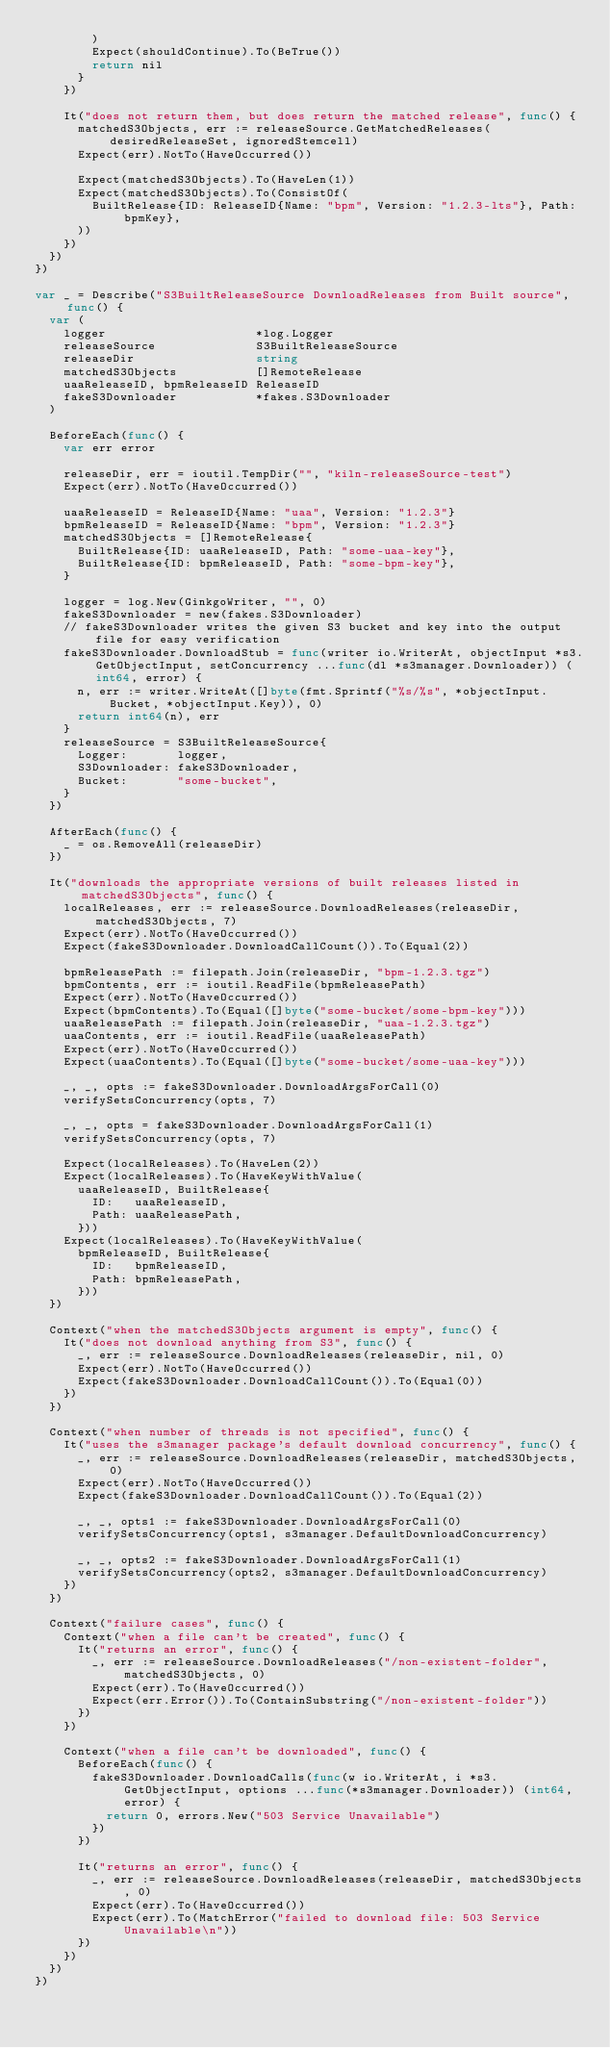<code> <loc_0><loc_0><loc_500><loc_500><_Go_>				)
				Expect(shouldContinue).To(BeTrue())
				return nil
			}
		})

		It("does not return them, but does return the matched release", func() {
			matchedS3Objects, err := releaseSource.GetMatchedReleases(desiredReleaseSet, ignoredStemcell)
			Expect(err).NotTo(HaveOccurred())

			Expect(matchedS3Objects).To(HaveLen(1))
			Expect(matchedS3Objects).To(ConsistOf(
				BuiltRelease{ID: ReleaseID{Name: "bpm", Version: "1.2.3-lts"}, Path: bpmKey},
			))
		})
	})
})

var _ = Describe("S3BuiltReleaseSource DownloadReleases from Built source", func() {
	var (
		logger                     *log.Logger
		releaseSource              S3BuiltReleaseSource
		releaseDir                 string
		matchedS3Objects           []RemoteRelease
		uaaReleaseID, bpmReleaseID ReleaseID
		fakeS3Downloader           *fakes.S3Downloader
	)

	BeforeEach(func() {
		var err error

		releaseDir, err = ioutil.TempDir("", "kiln-releaseSource-test")
		Expect(err).NotTo(HaveOccurred())

		uaaReleaseID = ReleaseID{Name: "uaa", Version: "1.2.3"}
		bpmReleaseID = ReleaseID{Name: "bpm", Version: "1.2.3"}
		matchedS3Objects = []RemoteRelease{
			BuiltRelease{ID: uaaReleaseID, Path: "some-uaa-key"},
			BuiltRelease{ID: bpmReleaseID, Path: "some-bpm-key"},
		}

		logger = log.New(GinkgoWriter, "", 0)
		fakeS3Downloader = new(fakes.S3Downloader)
		// fakeS3Downloader writes the given S3 bucket and key into the output file for easy verification
		fakeS3Downloader.DownloadStub = func(writer io.WriterAt, objectInput *s3.GetObjectInput, setConcurrency ...func(dl *s3manager.Downloader)) (int64, error) {
			n, err := writer.WriteAt([]byte(fmt.Sprintf("%s/%s", *objectInput.Bucket, *objectInput.Key)), 0)
			return int64(n), err
		}
		releaseSource = S3BuiltReleaseSource{
			Logger:       logger,
			S3Downloader: fakeS3Downloader,
			Bucket:       "some-bucket",
		}
	})

	AfterEach(func() {
		_ = os.RemoveAll(releaseDir)
	})

	It("downloads the appropriate versions of built releases listed in matchedS3Objects", func() {
		localReleases, err := releaseSource.DownloadReleases(releaseDir, matchedS3Objects, 7)
		Expect(err).NotTo(HaveOccurred())
		Expect(fakeS3Downloader.DownloadCallCount()).To(Equal(2))

		bpmReleasePath := filepath.Join(releaseDir, "bpm-1.2.3.tgz")
		bpmContents, err := ioutil.ReadFile(bpmReleasePath)
		Expect(err).NotTo(HaveOccurred())
		Expect(bpmContents).To(Equal([]byte("some-bucket/some-bpm-key")))
		uaaReleasePath := filepath.Join(releaseDir, "uaa-1.2.3.tgz")
		uaaContents, err := ioutil.ReadFile(uaaReleasePath)
		Expect(err).NotTo(HaveOccurred())
		Expect(uaaContents).To(Equal([]byte("some-bucket/some-uaa-key")))

		_, _, opts := fakeS3Downloader.DownloadArgsForCall(0)
		verifySetsConcurrency(opts, 7)

		_, _, opts = fakeS3Downloader.DownloadArgsForCall(1)
		verifySetsConcurrency(opts, 7)

		Expect(localReleases).To(HaveLen(2))
		Expect(localReleases).To(HaveKeyWithValue(
			uaaReleaseID, BuiltRelease{
				ID:   uaaReleaseID,
				Path: uaaReleasePath,
			}))
		Expect(localReleases).To(HaveKeyWithValue(
			bpmReleaseID, BuiltRelease{
				ID:   bpmReleaseID,
				Path: bpmReleasePath,
			}))
	})

	Context("when the matchedS3Objects argument is empty", func() {
		It("does not download anything from S3", func() {
			_, err := releaseSource.DownloadReleases(releaseDir, nil, 0)
			Expect(err).NotTo(HaveOccurred())
			Expect(fakeS3Downloader.DownloadCallCount()).To(Equal(0))
		})
	})

	Context("when number of threads is not specified", func() {
		It("uses the s3manager package's default download concurrency", func() {
			_, err := releaseSource.DownloadReleases(releaseDir, matchedS3Objects, 0)
			Expect(err).NotTo(HaveOccurred())
			Expect(fakeS3Downloader.DownloadCallCount()).To(Equal(2))

			_, _, opts1 := fakeS3Downloader.DownloadArgsForCall(0)
			verifySetsConcurrency(opts1, s3manager.DefaultDownloadConcurrency)

			_, _, opts2 := fakeS3Downloader.DownloadArgsForCall(1)
			verifySetsConcurrency(opts2, s3manager.DefaultDownloadConcurrency)
		})
	})

	Context("failure cases", func() {
		Context("when a file can't be created", func() {
			It("returns an error", func() {
				_, err := releaseSource.DownloadReleases("/non-existent-folder", matchedS3Objects, 0)
				Expect(err).To(HaveOccurred())
				Expect(err.Error()).To(ContainSubstring("/non-existent-folder"))
			})
		})

		Context("when a file can't be downloaded", func() {
			BeforeEach(func() {
				fakeS3Downloader.DownloadCalls(func(w io.WriterAt, i *s3.GetObjectInput, options ...func(*s3manager.Downloader)) (int64, error) {
					return 0, errors.New("503 Service Unavailable")
				})
			})

			It("returns an error", func() {
				_, err := releaseSource.DownloadReleases(releaseDir, matchedS3Objects, 0)
				Expect(err).To(HaveOccurred())
				Expect(err).To(MatchError("failed to download file: 503 Service Unavailable\n"))
			})
		})
	})
})
</code> 